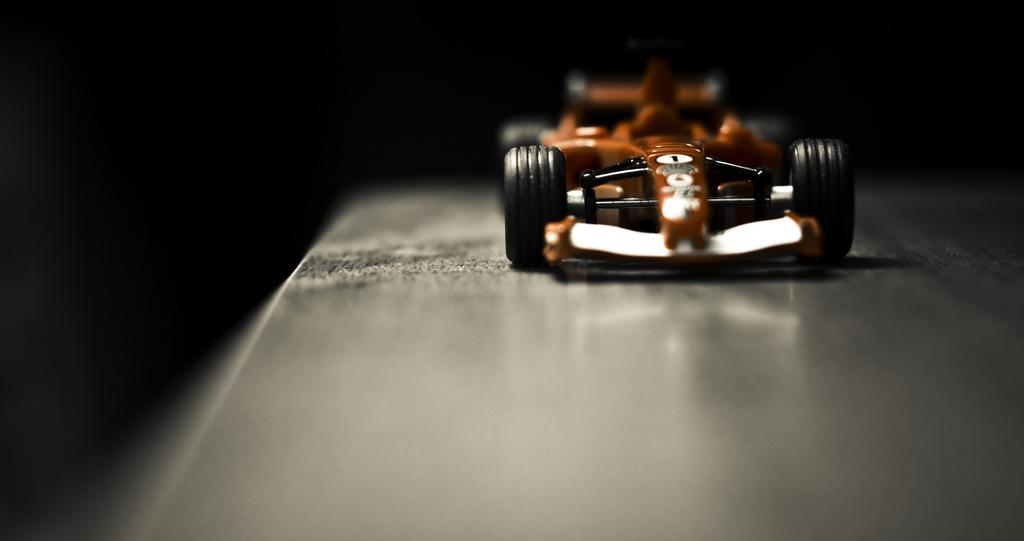What is the main subject of the image? There is a vehicle in the image. What colors are used for the vehicle? The vehicle has orange and black colors. What type of surface is the vehicle on? The vehicle is on a grey surface. What color is the background of the image? The background of the image is black. Can you tell me how the maid is adjusting the volcano in the image? There is no maid or volcano present in the image; it features a vehicle with orange and black colors on a grey surface against a black background. 